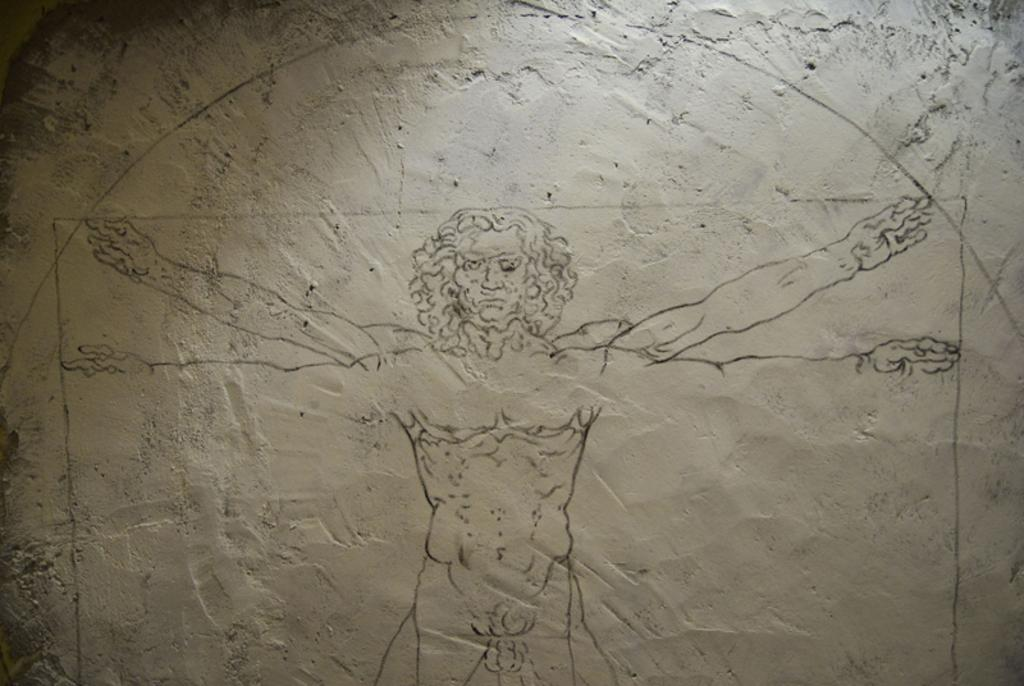What is present on the wall in the image? There is a design on the wall in the image. Can you describe the design on the wall? The design features a person. What type of camp can be seen in the image? There is no camp present in the image; it features a wall with a design that includes a person. 